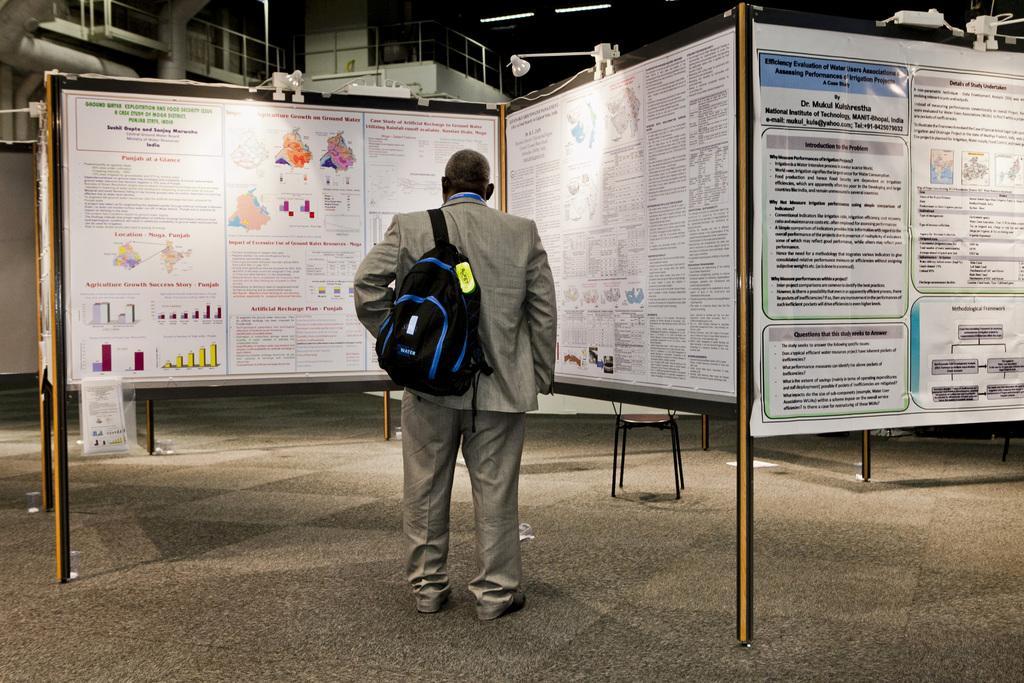Could you give a brief overview of what you see in this image? In this image I see a man who is wearing a bag and standing in front of the boards in which there are few papers on it. 